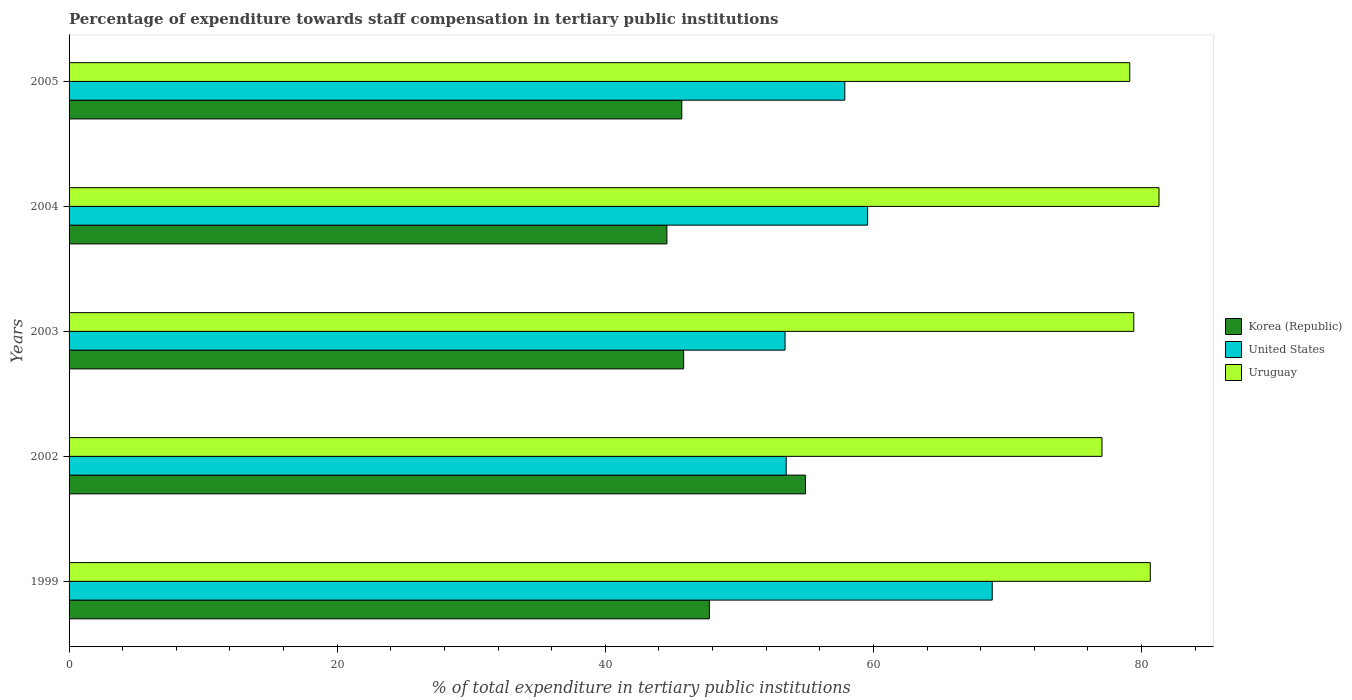How many groups of bars are there?
Offer a terse response. 5. How many bars are there on the 5th tick from the bottom?
Provide a short and direct response. 3. What is the label of the 3rd group of bars from the top?
Provide a short and direct response. 2003. What is the percentage of expenditure towards staff compensation in Korea (Republic) in 1999?
Keep it short and to the point. 47.76. Across all years, what is the maximum percentage of expenditure towards staff compensation in Korea (Republic)?
Provide a short and direct response. 54.93. Across all years, what is the minimum percentage of expenditure towards staff compensation in Korea (Republic)?
Your answer should be compact. 44.59. What is the total percentage of expenditure towards staff compensation in Uruguay in the graph?
Your response must be concise. 397.53. What is the difference between the percentage of expenditure towards staff compensation in Uruguay in 2002 and that in 2003?
Your answer should be very brief. -2.37. What is the difference between the percentage of expenditure towards staff compensation in United States in 2004 and the percentage of expenditure towards staff compensation in Uruguay in 2002?
Make the answer very short. -17.48. What is the average percentage of expenditure towards staff compensation in Korea (Republic) per year?
Your answer should be compact. 47.77. In the year 1999, what is the difference between the percentage of expenditure towards staff compensation in Korea (Republic) and percentage of expenditure towards staff compensation in United States?
Provide a succinct answer. -21.1. In how many years, is the percentage of expenditure towards staff compensation in Uruguay greater than 12 %?
Keep it short and to the point. 5. What is the ratio of the percentage of expenditure towards staff compensation in Uruguay in 2004 to that in 2005?
Provide a short and direct response. 1.03. Is the percentage of expenditure towards staff compensation in Uruguay in 2004 less than that in 2005?
Keep it short and to the point. No. Is the difference between the percentage of expenditure towards staff compensation in Korea (Republic) in 2002 and 2005 greater than the difference between the percentage of expenditure towards staff compensation in United States in 2002 and 2005?
Give a very brief answer. Yes. What is the difference between the highest and the second highest percentage of expenditure towards staff compensation in United States?
Provide a short and direct response. 9.29. What is the difference between the highest and the lowest percentage of expenditure towards staff compensation in United States?
Your answer should be compact. 15.45. Is the sum of the percentage of expenditure towards staff compensation in Korea (Republic) in 1999 and 2005 greater than the maximum percentage of expenditure towards staff compensation in Uruguay across all years?
Your response must be concise. Yes. What does the 1st bar from the top in 2004 represents?
Make the answer very short. Uruguay. What does the 3rd bar from the bottom in 2004 represents?
Make the answer very short. Uruguay. How many bars are there?
Your answer should be compact. 15. Are all the bars in the graph horizontal?
Your answer should be very brief. Yes. Are the values on the major ticks of X-axis written in scientific E-notation?
Ensure brevity in your answer.  No. Where does the legend appear in the graph?
Offer a very short reply. Center right. How are the legend labels stacked?
Provide a short and direct response. Vertical. What is the title of the graph?
Your answer should be compact. Percentage of expenditure towards staff compensation in tertiary public institutions. What is the label or title of the X-axis?
Provide a succinct answer. % of total expenditure in tertiary public institutions. What is the % of total expenditure in tertiary public institutions in Korea (Republic) in 1999?
Give a very brief answer. 47.76. What is the % of total expenditure in tertiary public institutions in United States in 1999?
Offer a very short reply. 68.86. What is the % of total expenditure in tertiary public institutions in Uruguay in 1999?
Give a very brief answer. 80.65. What is the % of total expenditure in tertiary public institutions of Korea (Republic) in 2002?
Provide a succinct answer. 54.93. What is the % of total expenditure in tertiary public institutions in United States in 2002?
Provide a short and direct response. 53.49. What is the % of total expenditure in tertiary public institutions in Uruguay in 2002?
Give a very brief answer. 77.05. What is the % of total expenditure in tertiary public institutions of Korea (Republic) in 2003?
Provide a succinct answer. 45.84. What is the % of total expenditure in tertiary public institutions of United States in 2003?
Your answer should be compact. 53.41. What is the % of total expenditure in tertiary public institutions in Uruguay in 2003?
Your answer should be very brief. 79.42. What is the % of total expenditure in tertiary public institutions in Korea (Republic) in 2004?
Offer a terse response. 44.59. What is the % of total expenditure in tertiary public institutions of United States in 2004?
Provide a short and direct response. 59.56. What is the % of total expenditure in tertiary public institutions of Uruguay in 2004?
Your response must be concise. 81.3. What is the % of total expenditure in tertiary public institutions in Korea (Republic) in 2005?
Offer a very short reply. 45.71. What is the % of total expenditure in tertiary public institutions in United States in 2005?
Provide a short and direct response. 57.86. What is the % of total expenditure in tertiary public institutions in Uruguay in 2005?
Keep it short and to the point. 79.12. Across all years, what is the maximum % of total expenditure in tertiary public institutions of Korea (Republic)?
Make the answer very short. 54.93. Across all years, what is the maximum % of total expenditure in tertiary public institutions in United States?
Provide a short and direct response. 68.86. Across all years, what is the maximum % of total expenditure in tertiary public institutions of Uruguay?
Offer a very short reply. 81.3. Across all years, what is the minimum % of total expenditure in tertiary public institutions in Korea (Republic)?
Give a very brief answer. 44.59. Across all years, what is the minimum % of total expenditure in tertiary public institutions in United States?
Offer a terse response. 53.41. Across all years, what is the minimum % of total expenditure in tertiary public institutions of Uruguay?
Give a very brief answer. 77.05. What is the total % of total expenditure in tertiary public institutions of Korea (Republic) in the graph?
Provide a succinct answer. 238.83. What is the total % of total expenditure in tertiary public institutions of United States in the graph?
Your answer should be very brief. 293.19. What is the total % of total expenditure in tertiary public institutions in Uruguay in the graph?
Make the answer very short. 397.53. What is the difference between the % of total expenditure in tertiary public institutions in Korea (Republic) in 1999 and that in 2002?
Your response must be concise. -7.16. What is the difference between the % of total expenditure in tertiary public institutions of United States in 1999 and that in 2002?
Provide a short and direct response. 15.37. What is the difference between the % of total expenditure in tertiary public institutions in Uruguay in 1999 and that in 2002?
Ensure brevity in your answer.  3.6. What is the difference between the % of total expenditure in tertiary public institutions of Korea (Republic) in 1999 and that in 2003?
Your answer should be compact. 1.92. What is the difference between the % of total expenditure in tertiary public institutions in United States in 1999 and that in 2003?
Make the answer very short. 15.45. What is the difference between the % of total expenditure in tertiary public institutions in Uruguay in 1999 and that in 2003?
Keep it short and to the point. 1.23. What is the difference between the % of total expenditure in tertiary public institutions in Korea (Republic) in 1999 and that in 2004?
Offer a very short reply. 3.17. What is the difference between the % of total expenditure in tertiary public institutions of United States in 1999 and that in 2004?
Your answer should be compact. 9.29. What is the difference between the % of total expenditure in tertiary public institutions in Uruguay in 1999 and that in 2004?
Your answer should be compact. -0.65. What is the difference between the % of total expenditure in tertiary public institutions of Korea (Republic) in 1999 and that in 2005?
Provide a short and direct response. 2.06. What is the difference between the % of total expenditure in tertiary public institutions in United States in 1999 and that in 2005?
Your answer should be very brief. 11. What is the difference between the % of total expenditure in tertiary public institutions in Uruguay in 1999 and that in 2005?
Make the answer very short. 1.53. What is the difference between the % of total expenditure in tertiary public institutions of Korea (Republic) in 2002 and that in 2003?
Keep it short and to the point. 9.09. What is the difference between the % of total expenditure in tertiary public institutions in United States in 2002 and that in 2003?
Make the answer very short. 0.09. What is the difference between the % of total expenditure in tertiary public institutions in Uruguay in 2002 and that in 2003?
Your response must be concise. -2.37. What is the difference between the % of total expenditure in tertiary public institutions of Korea (Republic) in 2002 and that in 2004?
Your response must be concise. 10.34. What is the difference between the % of total expenditure in tertiary public institutions in United States in 2002 and that in 2004?
Provide a short and direct response. -6.07. What is the difference between the % of total expenditure in tertiary public institutions of Uruguay in 2002 and that in 2004?
Ensure brevity in your answer.  -4.25. What is the difference between the % of total expenditure in tertiary public institutions of Korea (Republic) in 2002 and that in 2005?
Provide a short and direct response. 9.22. What is the difference between the % of total expenditure in tertiary public institutions of United States in 2002 and that in 2005?
Offer a terse response. -4.37. What is the difference between the % of total expenditure in tertiary public institutions of Uruguay in 2002 and that in 2005?
Your response must be concise. -2.07. What is the difference between the % of total expenditure in tertiary public institutions of Korea (Republic) in 2003 and that in 2004?
Ensure brevity in your answer.  1.25. What is the difference between the % of total expenditure in tertiary public institutions in United States in 2003 and that in 2004?
Make the answer very short. -6.16. What is the difference between the % of total expenditure in tertiary public institutions in Uruguay in 2003 and that in 2004?
Your response must be concise. -1.88. What is the difference between the % of total expenditure in tertiary public institutions of Korea (Republic) in 2003 and that in 2005?
Your answer should be compact. 0.14. What is the difference between the % of total expenditure in tertiary public institutions of United States in 2003 and that in 2005?
Give a very brief answer. -4.46. What is the difference between the % of total expenditure in tertiary public institutions in Uruguay in 2003 and that in 2005?
Your answer should be compact. 0.3. What is the difference between the % of total expenditure in tertiary public institutions of Korea (Republic) in 2004 and that in 2005?
Keep it short and to the point. -1.11. What is the difference between the % of total expenditure in tertiary public institutions in United States in 2004 and that in 2005?
Offer a very short reply. 1.7. What is the difference between the % of total expenditure in tertiary public institutions of Uruguay in 2004 and that in 2005?
Keep it short and to the point. 2.18. What is the difference between the % of total expenditure in tertiary public institutions in Korea (Republic) in 1999 and the % of total expenditure in tertiary public institutions in United States in 2002?
Offer a very short reply. -5.73. What is the difference between the % of total expenditure in tertiary public institutions in Korea (Republic) in 1999 and the % of total expenditure in tertiary public institutions in Uruguay in 2002?
Your answer should be compact. -29.28. What is the difference between the % of total expenditure in tertiary public institutions in United States in 1999 and the % of total expenditure in tertiary public institutions in Uruguay in 2002?
Your answer should be compact. -8.19. What is the difference between the % of total expenditure in tertiary public institutions of Korea (Republic) in 1999 and the % of total expenditure in tertiary public institutions of United States in 2003?
Give a very brief answer. -5.64. What is the difference between the % of total expenditure in tertiary public institutions in Korea (Republic) in 1999 and the % of total expenditure in tertiary public institutions in Uruguay in 2003?
Make the answer very short. -31.65. What is the difference between the % of total expenditure in tertiary public institutions in United States in 1999 and the % of total expenditure in tertiary public institutions in Uruguay in 2003?
Your response must be concise. -10.56. What is the difference between the % of total expenditure in tertiary public institutions of Korea (Republic) in 1999 and the % of total expenditure in tertiary public institutions of United States in 2004?
Offer a terse response. -11.8. What is the difference between the % of total expenditure in tertiary public institutions in Korea (Republic) in 1999 and the % of total expenditure in tertiary public institutions in Uruguay in 2004?
Your answer should be compact. -33.54. What is the difference between the % of total expenditure in tertiary public institutions in United States in 1999 and the % of total expenditure in tertiary public institutions in Uruguay in 2004?
Your answer should be very brief. -12.44. What is the difference between the % of total expenditure in tertiary public institutions in Korea (Republic) in 1999 and the % of total expenditure in tertiary public institutions in United States in 2005?
Your answer should be very brief. -10.1. What is the difference between the % of total expenditure in tertiary public institutions of Korea (Republic) in 1999 and the % of total expenditure in tertiary public institutions of Uruguay in 2005?
Offer a very short reply. -31.35. What is the difference between the % of total expenditure in tertiary public institutions of United States in 1999 and the % of total expenditure in tertiary public institutions of Uruguay in 2005?
Your answer should be very brief. -10.26. What is the difference between the % of total expenditure in tertiary public institutions in Korea (Republic) in 2002 and the % of total expenditure in tertiary public institutions in United States in 2003?
Ensure brevity in your answer.  1.52. What is the difference between the % of total expenditure in tertiary public institutions of Korea (Republic) in 2002 and the % of total expenditure in tertiary public institutions of Uruguay in 2003?
Make the answer very short. -24.49. What is the difference between the % of total expenditure in tertiary public institutions of United States in 2002 and the % of total expenditure in tertiary public institutions of Uruguay in 2003?
Keep it short and to the point. -25.93. What is the difference between the % of total expenditure in tertiary public institutions in Korea (Republic) in 2002 and the % of total expenditure in tertiary public institutions in United States in 2004?
Your answer should be very brief. -4.64. What is the difference between the % of total expenditure in tertiary public institutions of Korea (Republic) in 2002 and the % of total expenditure in tertiary public institutions of Uruguay in 2004?
Provide a short and direct response. -26.37. What is the difference between the % of total expenditure in tertiary public institutions of United States in 2002 and the % of total expenditure in tertiary public institutions of Uruguay in 2004?
Make the answer very short. -27.81. What is the difference between the % of total expenditure in tertiary public institutions of Korea (Republic) in 2002 and the % of total expenditure in tertiary public institutions of United States in 2005?
Your answer should be very brief. -2.94. What is the difference between the % of total expenditure in tertiary public institutions in Korea (Republic) in 2002 and the % of total expenditure in tertiary public institutions in Uruguay in 2005?
Provide a succinct answer. -24.19. What is the difference between the % of total expenditure in tertiary public institutions of United States in 2002 and the % of total expenditure in tertiary public institutions of Uruguay in 2005?
Your response must be concise. -25.63. What is the difference between the % of total expenditure in tertiary public institutions in Korea (Republic) in 2003 and the % of total expenditure in tertiary public institutions in United States in 2004?
Provide a succinct answer. -13.72. What is the difference between the % of total expenditure in tertiary public institutions in Korea (Republic) in 2003 and the % of total expenditure in tertiary public institutions in Uruguay in 2004?
Your answer should be very brief. -35.46. What is the difference between the % of total expenditure in tertiary public institutions of United States in 2003 and the % of total expenditure in tertiary public institutions of Uruguay in 2004?
Give a very brief answer. -27.89. What is the difference between the % of total expenditure in tertiary public institutions of Korea (Republic) in 2003 and the % of total expenditure in tertiary public institutions of United States in 2005?
Offer a terse response. -12.02. What is the difference between the % of total expenditure in tertiary public institutions in Korea (Republic) in 2003 and the % of total expenditure in tertiary public institutions in Uruguay in 2005?
Keep it short and to the point. -33.28. What is the difference between the % of total expenditure in tertiary public institutions in United States in 2003 and the % of total expenditure in tertiary public institutions in Uruguay in 2005?
Offer a terse response. -25.71. What is the difference between the % of total expenditure in tertiary public institutions of Korea (Republic) in 2004 and the % of total expenditure in tertiary public institutions of United States in 2005?
Offer a very short reply. -13.27. What is the difference between the % of total expenditure in tertiary public institutions of Korea (Republic) in 2004 and the % of total expenditure in tertiary public institutions of Uruguay in 2005?
Ensure brevity in your answer.  -34.53. What is the difference between the % of total expenditure in tertiary public institutions in United States in 2004 and the % of total expenditure in tertiary public institutions in Uruguay in 2005?
Your answer should be very brief. -19.55. What is the average % of total expenditure in tertiary public institutions in Korea (Republic) per year?
Your answer should be compact. 47.77. What is the average % of total expenditure in tertiary public institutions in United States per year?
Ensure brevity in your answer.  58.64. What is the average % of total expenditure in tertiary public institutions of Uruguay per year?
Offer a very short reply. 79.51. In the year 1999, what is the difference between the % of total expenditure in tertiary public institutions of Korea (Republic) and % of total expenditure in tertiary public institutions of United States?
Provide a succinct answer. -21.1. In the year 1999, what is the difference between the % of total expenditure in tertiary public institutions in Korea (Republic) and % of total expenditure in tertiary public institutions in Uruguay?
Provide a succinct answer. -32.89. In the year 1999, what is the difference between the % of total expenditure in tertiary public institutions in United States and % of total expenditure in tertiary public institutions in Uruguay?
Keep it short and to the point. -11.79. In the year 2002, what is the difference between the % of total expenditure in tertiary public institutions of Korea (Republic) and % of total expenditure in tertiary public institutions of United States?
Make the answer very short. 1.44. In the year 2002, what is the difference between the % of total expenditure in tertiary public institutions in Korea (Republic) and % of total expenditure in tertiary public institutions in Uruguay?
Your answer should be very brief. -22.12. In the year 2002, what is the difference between the % of total expenditure in tertiary public institutions of United States and % of total expenditure in tertiary public institutions of Uruguay?
Ensure brevity in your answer.  -23.55. In the year 2003, what is the difference between the % of total expenditure in tertiary public institutions of Korea (Republic) and % of total expenditure in tertiary public institutions of United States?
Keep it short and to the point. -7.56. In the year 2003, what is the difference between the % of total expenditure in tertiary public institutions of Korea (Republic) and % of total expenditure in tertiary public institutions of Uruguay?
Keep it short and to the point. -33.57. In the year 2003, what is the difference between the % of total expenditure in tertiary public institutions of United States and % of total expenditure in tertiary public institutions of Uruguay?
Your response must be concise. -26.01. In the year 2004, what is the difference between the % of total expenditure in tertiary public institutions of Korea (Republic) and % of total expenditure in tertiary public institutions of United States?
Ensure brevity in your answer.  -14.97. In the year 2004, what is the difference between the % of total expenditure in tertiary public institutions in Korea (Republic) and % of total expenditure in tertiary public institutions in Uruguay?
Provide a succinct answer. -36.71. In the year 2004, what is the difference between the % of total expenditure in tertiary public institutions of United States and % of total expenditure in tertiary public institutions of Uruguay?
Make the answer very short. -21.74. In the year 2005, what is the difference between the % of total expenditure in tertiary public institutions of Korea (Republic) and % of total expenditure in tertiary public institutions of United States?
Offer a very short reply. -12.16. In the year 2005, what is the difference between the % of total expenditure in tertiary public institutions in Korea (Republic) and % of total expenditure in tertiary public institutions in Uruguay?
Your answer should be very brief. -33.41. In the year 2005, what is the difference between the % of total expenditure in tertiary public institutions of United States and % of total expenditure in tertiary public institutions of Uruguay?
Give a very brief answer. -21.25. What is the ratio of the % of total expenditure in tertiary public institutions of Korea (Republic) in 1999 to that in 2002?
Offer a very short reply. 0.87. What is the ratio of the % of total expenditure in tertiary public institutions in United States in 1999 to that in 2002?
Keep it short and to the point. 1.29. What is the ratio of the % of total expenditure in tertiary public institutions of Uruguay in 1999 to that in 2002?
Offer a terse response. 1.05. What is the ratio of the % of total expenditure in tertiary public institutions in Korea (Republic) in 1999 to that in 2003?
Offer a very short reply. 1.04. What is the ratio of the % of total expenditure in tertiary public institutions of United States in 1999 to that in 2003?
Keep it short and to the point. 1.29. What is the ratio of the % of total expenditure in tertiary public institutions in Uruguay in 1999 to that in 2003?
Ensure brevity in your answer.  1.02. What is the ratio of the % of total expenditure in tertiary public institutions of Korea (Republic) in 1999 to that in 2004?
Provide a succinct answer. 1.07. What is the ratio of the % of total expenditure in tertiary public institutions of United States in 1999 to that in 2004?
Your response must be concise. 1.16. What is the ratio of the % of total expenditure in tertiary public institutions of Korea (Republic) in 1999 to that in 2005?
Your answer should be very brief. 1.04. What is the ratio of the % of total expenditure in tertiary public institutions of United States in 1999 to that in 2005?
Your answer should be compact. 1.19. What is the ratio of the % of total expenditure in tertiary public institutions in Uruguay in 1999 to that in 2005?
Offer a very short reply. 1.02. What is the ratio of the % of total expenditure in tertiary public institutions in Korea (Republic) in 2002 to that in 2003?
Keep it short and to the point. 1.2. What is the ratio of the % of total expenditure in tertiary public institutions of Uruguay in 2002 to that in 2003?
Make the answer very short. 0.97. What is the ratio of the % of total expenditure in tertiary public institutions in Korea (Republic) in 2002 to that in 2004?
Provide a short and direct response. 1.23. What is the ratio of the % of total expenditure in tertiary public institutions of United States in 2002 to that in 2004?
Your answer should be very brief. 0.9. What is the ratio of the % of total expenditure in tertiary public institutions in Uruguay in 2002 to that in 2004?
Offer a terse response. 0.95. What is the ratio of the % of total expenditure in tertiary public institutions in Korea (Republic) in 2002 to that in 2005?
Offer a terse response. 1.2. What is the ratio of the % of total expenditure in tertiary public institutions in United States in 2002 to that in 2005?
Your response must be concise. 0.92. What is the ratio of the % of total expenditure in tertiary public institutions in Uruguay in 2002 to that in 2005?
Ensure brevity in your answer.  0.97. What is the ratio of the % of total expenditure in tertiary public institutions of Korea (Republic) in 2003 to that in 2004?
Your answer should be very brief. 1.03. What is the ratio of the % of total expenditure in tertiary public institutions in United States in 2003 to that in 2004?
Your response must be concise. 0.9. What is the ratio of the % of total expenditure in tertiary public institutions of Uruguay in 2003 to that in 2004?
Your answer should be compact. 0.98. What is the ratio of the % of total expenditure in tertiary public institutions in United States in 2003 to that in 2005?
Keep it short and to the point. 0.92. What is the ratio of the % of total expenditure in tertiary public institutions of Korea (Republic) in 2004 to that in 2005?
Your response must be concise. 0.98. What is the ratio of the % of total expenditure in tertiary public institutions of United States in 2004 to that in 2005?
Your answer should be compact. 1.03. What is the ratio of the % of total expenditure in tertiary public institutions in Uruguay in 2004 to that in 2005?
Offer a terse response. 1.03. What is the difference between the highest and the second highest % of total expenditure in tertiary public institutions of Korea (Republic)?
Your answer should be very brief. 7.16. What is the difference between the highest and the second highest % of total expenditure in tertiary public institutions of United States?
Make the answer very short. 9.29. What is the difference between the highest and the second highest % of total expenditure in tertiary public institutions in Uruguay?
Make the answer very short. 0.65. What is the difference between the highest and the lowest % of total expenditure in tertiary public institutions of Korea (Republic)?
Offer a terse response. 10.34. What is the difference between the highest and the lowest % of total expenditure in tertiary public institutions in United States?
Your response must be concise. 15.45. What is the difference between the highest and the lowest % of total expenditure in tertiary public institutions in Uruguay?
Provide a succinct answer. 4.25. 